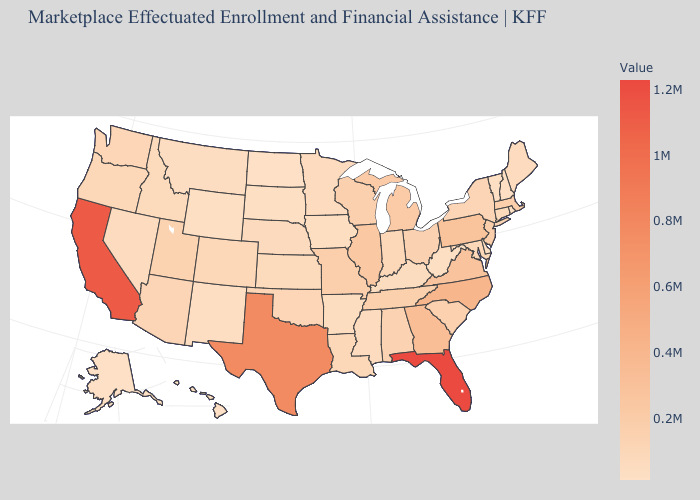Which states have the lowest value in the USA?
Keep it brief. Alaska. Which states have the lowest value in the USA?
Concise answer only. Alaska. Is the legend a continuous bar?
Give a very brief answer. Yes. Does Montana have a higher value than Tennessee?
Quick response, please. No. Which states hav the highest value in the South?
Concise answer only. Florida. 